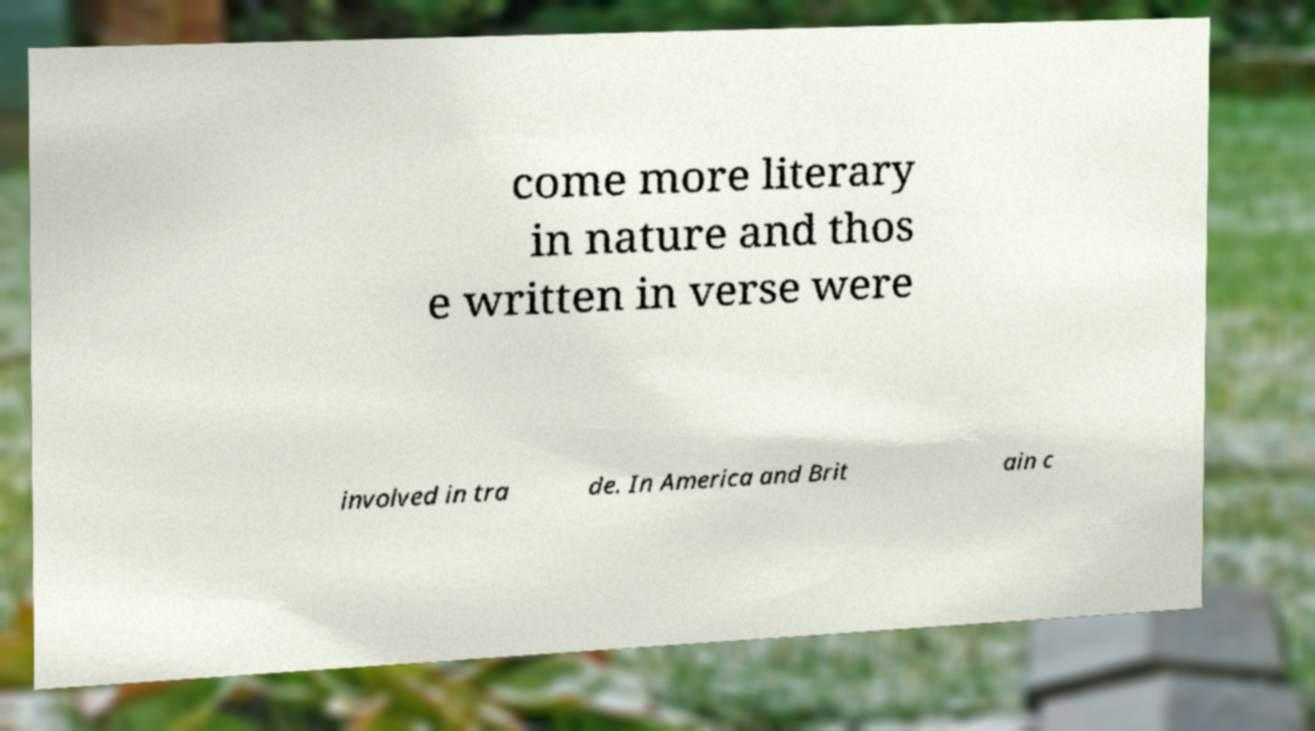Can you read and provide the text displayed in the image?This photo seems to have some interesting text. Can you extract and type it out for me? come more literary in nature and thos e written in verse were involved in tra de. In America and Brit ain c 